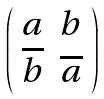Convert formula to latex. <formula><loc_0><loc_0><loc_500><loc_500>\left ( \begin{array} { c c } a & b \\ \overline { b } & \overline { a } \end{array} \right )</formula> 